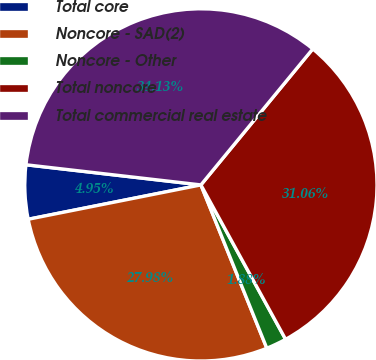Convert chart. <chart><loc_0><loc_0><loc_500><loc_500><pie_chart><fcel>Total core<fcel>Noncore - SAD(2)<fcel>Noncore - Other<fcel>Total noncore<fcel>Total commercial real estate<nl><fcel>4.95%<fcel>27.98%<fcel>1.88%<fcel>31.06%<fcel>34.13%<nl></chart> 